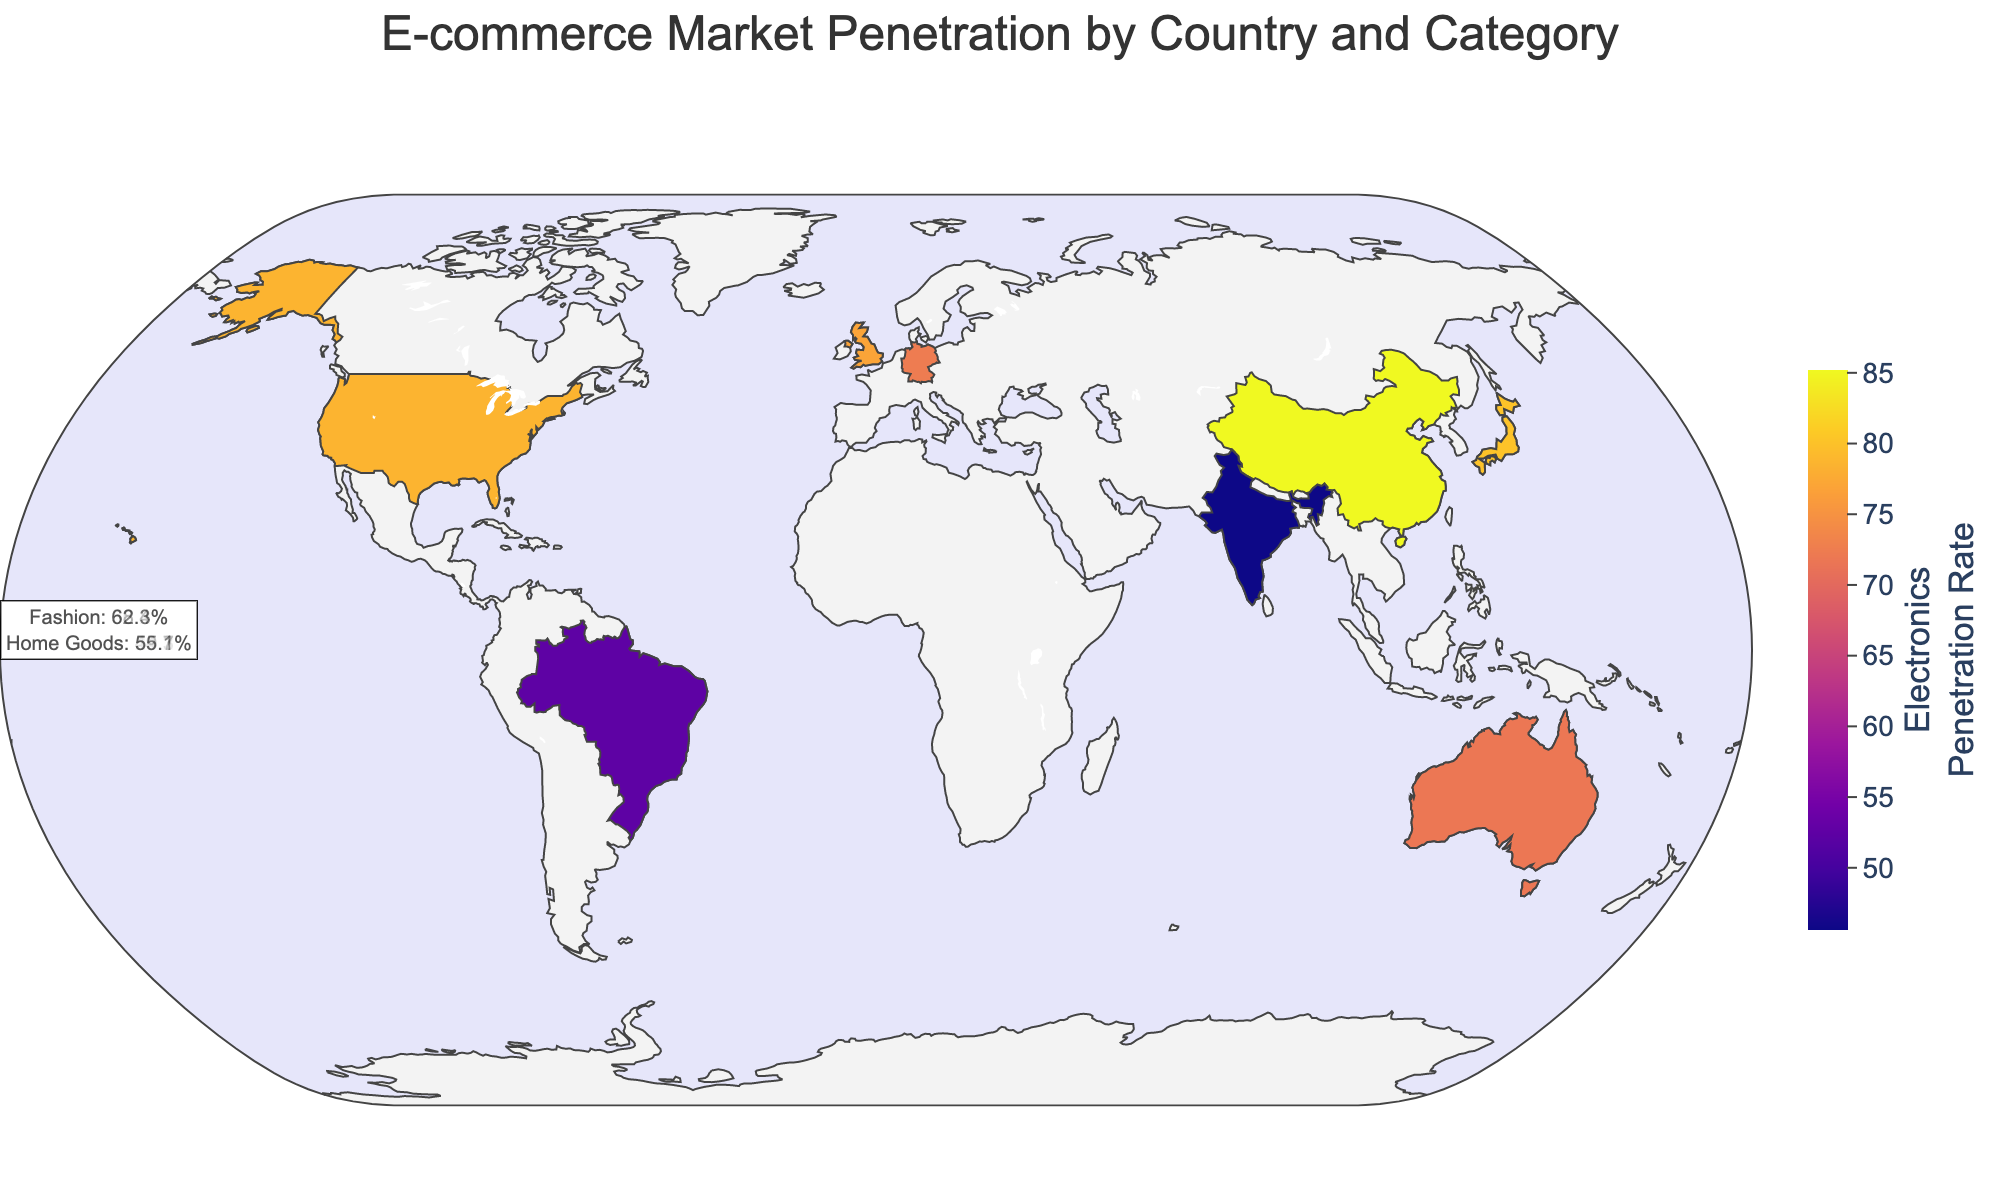What's the title of the figure? The title is located at the top of the figure. It summarizes the content and purpose of the plot.
Answer: E-commerce Market Penetration by Country and Category Which country has the highest penetration rate for Electronics? The color scale and hover information can be used to identify the country with the highest penetration rate for Electronics.
Answer: China How does the Fashion penetration rate in the United States compare to that in the United Kingdom? By checking the hover data for both the United States and the United Kingdom, you can compare their Fashion penetration rates.
Answer: The United States has a lower Fashion penetration rate (62.3%) compared to the United Kingdom (68.4%) What is the average penetration rate for Home Goods across all countries? To find the average, sum the penetration rates for Home Goods across all countries and divide by the number of countries. (55.1 + 48.9 + 59.7 + 51.2 + 29.7 + 44.3 + 35.6 + 57.2) / 8 = 47.2
Answer: 47.2 In which country is the difference between Electronics and Home Goods penetration rate the largest? Calculate the difference between Electronics and Home Goods penetration rates for each country and find the largest difference. China: 85.2 - 48.9 = 36.3; India: 45.6 - 29.7 = 15.9; USA: 78.5 - 55.1 = 23.4; UK: 76.9 - 59.7 = 17.2; Germany: 14.6; Japan: 35.8; Brazil: 16.8; Australia: 14.6. The largest difference is in China (36.3).
Answer: China Compare the penetration rates for Electronics and Fashion in Japan. Which is higher and by how much? Check the hover data for Japan and compare the penetration rates for both categories. Electronics: 80.1%, Fashion: 56.8%. The difference is 80.1 - 56.8 = 23.3%.
Answer: Electronics is higher by 23.3% Which country has the most even distribution of penetration rates across the three categories? Look at the annotations for each country and find the one with the smallest range (difference between highest and lowest rates). Australia: 71.8, 64.5, 57.2, range = 14.6; Germany: 72.3, 58.1, 51.2, range = 21.1; UK: 76.9, 68.4, 59.7, range = 17.2; US: 78.5, 62.3, 55.1, range = 23.4; China: 85.2, 70.6, 48.9, range = 36.3; Brazil: 52.4, 47.9, 35.6, range = 16.8; India: range = 15.9; Japan: range = 35.8. Australia has the most even distribution with a range of 14.6.
Answer: Australia 